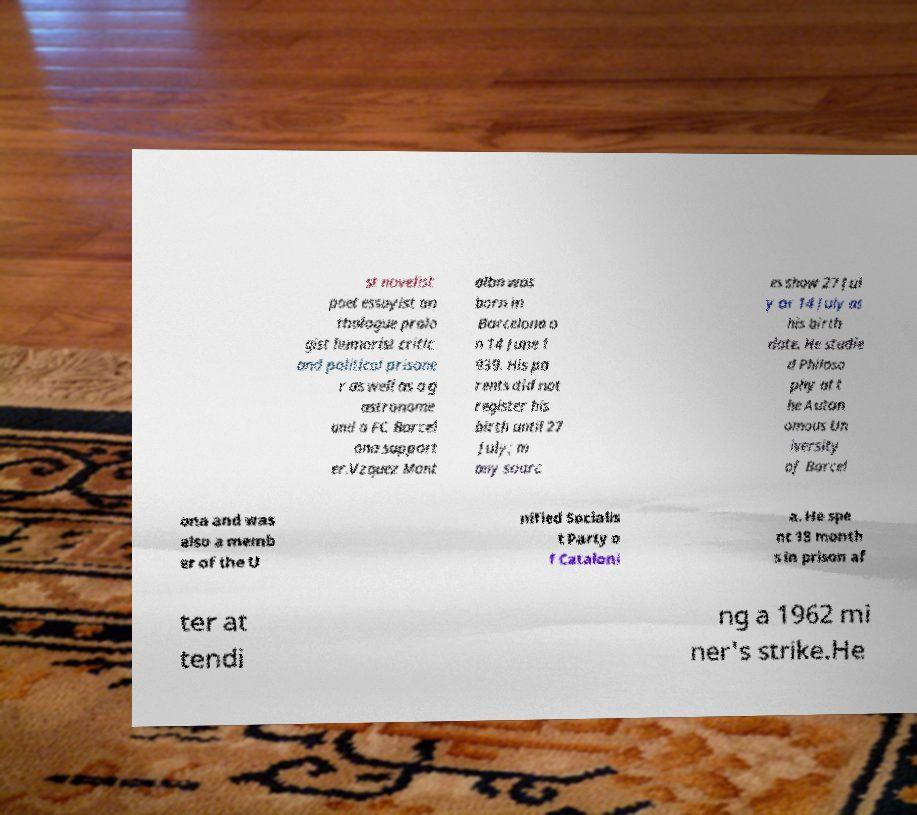I need the written content from this picture converted into text. Can you do that? st novelist poet essayist an thologue prolo gist humorist critic and political prisone r as well as a g astronome and a FC Barcel ona support er.Vzquez Mont albn was born in Barcelona o n 14 June 1 939. His pa rents did not register his birth until 27 July; m any sourc es show 27 Jul y or 14 July as his birth date. He studie d Philoso phy at t he Auton omous Un iversity of Barcel ona and was also a memb er of the U nified Socialis t Party o f Cataloni a. He spe nt 18 month s in prison af ter at tendi ng a 1962 mi ner's strike.He 